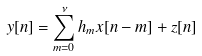<formula> <loc_0><loc_0><loc_500><loc_500>y [ n ] & = \sum _ { m = 0 } ^ { \nu } h _ { m } x [ n - m ] + z [ n ]</formula> 